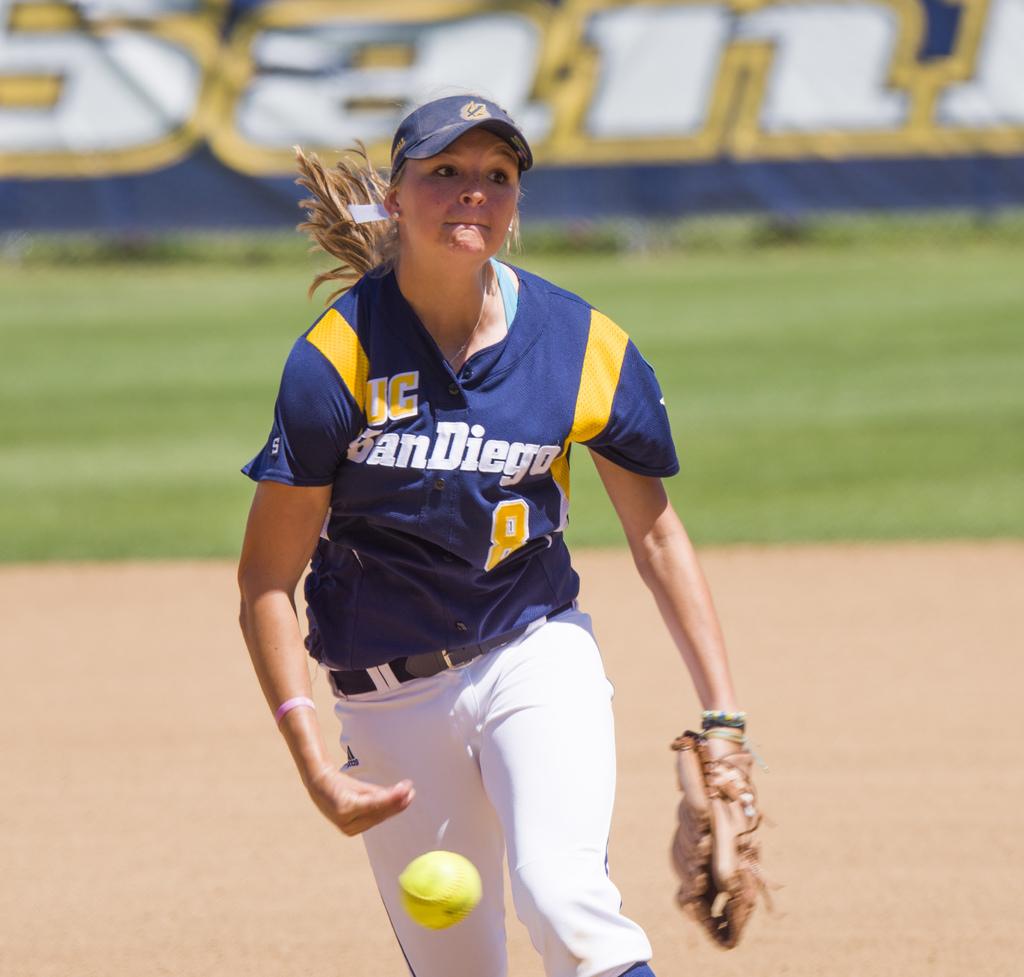Where is the home city of player 8's team?
Keep it short and to the point. San diego. What is her jersey number?
Your answer should be very brief. 8. 